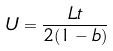<formula> <loc_0><loc_0><loc_500><loc_500>U = \frac { L t } { 2 ( 1 - b ) }</formula> 